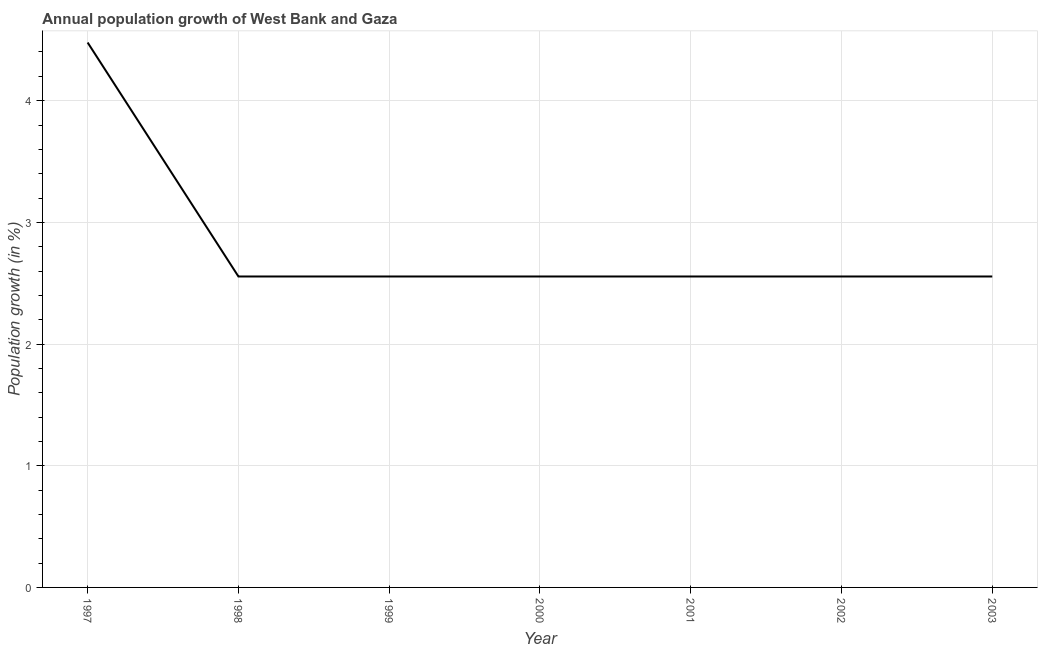What is the population growth in 2000?
Offer a terse response. 2.56. Across all years, what is the maximum population growth?
Give a very brief answer. 4.48. Across all years, what is the minimum population growth?
Ensure brevity in your answer.  2.56. In which year was the population growth minimum?
Your answer should be compact. 2000. What is the sum of the population growth?
Offer a very short reply. 19.81. What is the difference between the population growth in 1999 and 2001?
Provide a succinct answer. 8.00511680054683e-7. What is the average population growth per year?
Offer a very short reply. 2.83. What is the median population growth?
Your answer should be compact. 2.56. In how many years, is the population growth greater than 2.2 %?
Offer a terse response. 7. Do a majority of the years between 1998 and 2002 (inclusive) have population growth greater than 0.8 %?
Your answer should be compact. Yes. What is the ratio of the population growth in 1999 to that in 2002?
Give a very brief answer. 1. Is the difference between the population growth in 2001 and 2002 greater than the difference between any two years?
Your answer should be compact. No. What is the difference between the highest and the second highest population growth?
Offer a very short reply. 1.92. Is the sum of the population growth in 1997 and 2002 greater than the maximum population growth across all years?
Offer a terse response. Yes. What is the difference between the highest and the lowest population growth?
Ensure brevity in your answer.  1.92. How many years are there in the graph?
Your answer should be very brief. 7. Are the values on the major ticks of Y-axis written in scientific E-notation?
Keep it short and to the point. No. Does the graph contain grids?
Your answer should be compact. Yes. What is the title of the graph?
Provide a short and direct response. Annual population growth of West Bank and Gaza. What is the label or title of the Y-axis?
Provide a short and direct response. Population growth (in %). What is the Population growth (in %) in 1997?
Give a very brief answer. 4.48. What is the Population growth (in %) of 1998?
Your answer should be very brief. 2.56. What is the Population growth (in %) of 1999?
Offer a terse response. 2.56. What is the Population growth (in %) in 2000?
Offer a very short reply. 2.56. What is the Population growth (in %) of 2001?
Give a very brief answer. 2.56. What is the Population growth (in %) in 2002?
Make the answer very short. 2.56. What is the Population growth (in %) of 2003?
Your answer should be compact. 2.56. What is the difference between the Population growth (in %) in 1997 and 1998?
Provide a short and direct response. 1.92. What is the difference between the Population growth (in %) in 1997 and 1999?
Provide a succinct answer. 1.92. What is the difference between the Population growth (in %) in 1997 and 2000?
Your response must be concise. 1.92. What is the difference between the Population growth (in %) in 1997 and 2001?
Keep it short and to the point. 1.92. What is the difference between the Population growth (in %) in 1997 and 2002?
Offer a very short reply. 1.92. What is the difference between the Population growth (in %) in 1997 and 2003?
Your answer should be very brief. 1.92. What is the difference between the Population growth (in %) in 1998 and 2000?
Provide a short and direct response. 3e-5. What is the difference between the Population growth (in %) in 1998 and 2001?
Your response must be concise. 0. What is the difference between the Population growth (in %) in 1998 and 2002?
Keep it short and to the point. -2e-5. What is the difference between the Population growth (in %) in 1998 and 2003?
Provide a short and direct response. 2e-5. What is the difference between the Population growth (in %) in 1999 and 2000?
Your answer should be very brief. 3e-5. What is the difference between the Population growth (in %) in 1999 and 2002?
Offer a very short reply. -2e-5. What is the difference between the Population growth (in %) in 1999 and 2003?
Provide a succinct answer. 2e-5. What is the difference between the Population growth (in %) in 2000 and 2001?
Give a very brief answer. -3e-5. What is the difference between the Population growth (in %) in 2000 and 2002?
Give a very brief answer. -5e-5. What is the difference between the Population growth (in %) in 2000 and 2003?
Keep it short and to the point. -1e-5. What is the difference between the Population growth (in %) in 2001 and 2002?
Your answer should be very brief. -2e-5. What is the difference between the Population growth (in %) in 2001 and 2003?
Your answer should be compact. 2e-5. What is the difference between the Population growth (in %) in 2002 and 2003?
Ensure brevity in your answer.  4e-5. What is the ratio of the Population growth (in %) in 1997 to that in 1998?
Ensure brevity in your answer.  1.75. What is the ratio of the Population growth (in %) in 1997 to that in 1999?
Your response must be concise. 1.75. What is the ratio of the Population growth (in %) in 1997 to that in 2000?
Ensure brevity in your answer.  1.75. What is the ratio of the Population growth (in %) in 1997 to that in 2001?
Make the answer very short. 1.75. What is the ratio of the Population growth (in %) in 1997 to that in 2002?
Your answer should be compact. 1.75. What is the ratio of the Population growth (in %) in 1997 to that in 2003?
Provide a succinct answer. 1.75. What is the ratio of the Population growth (in %) in 1998 to that in 1999?
Your response must be concise. 1. What is the ratio of the Population growth (in %) in 1999 to that in 2000?
Give a very brief answer. 1. What is the ratio of the Population growth (in %) in 2000 to that in 2002?
Give a very brief answer. 1. What is the ratio of the Population growth (in %) in 2000 to that in 2003?
Your response must be concise. 1. What is the ratio of the Population growth (in %) in 2001 to that in 2002?
Provide a succinct answer. 1. 